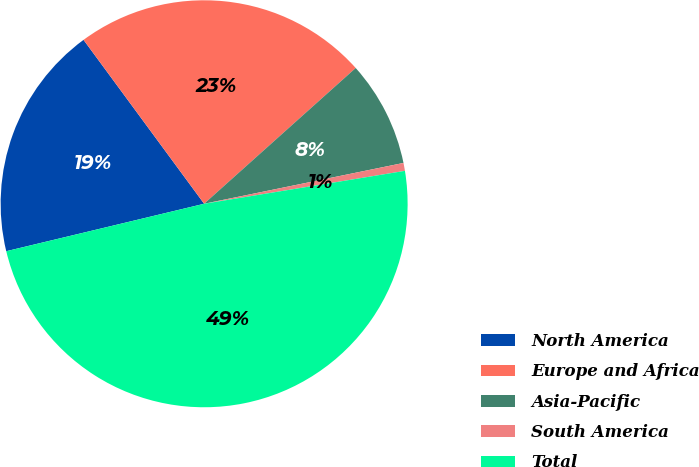Convert chart. <chart><loc_0><loc_0><loc_500><loc_500><pie_chart><fcel>North America<fcel>Europe and Africa<fcel>Asia-Pacific<fcel>South America<fcel>Total<nl><fcel>18.65%<fcel>23.47%<fcel>8.41%<fcel>0.63%<fcel>48.84%<nl></chart> 